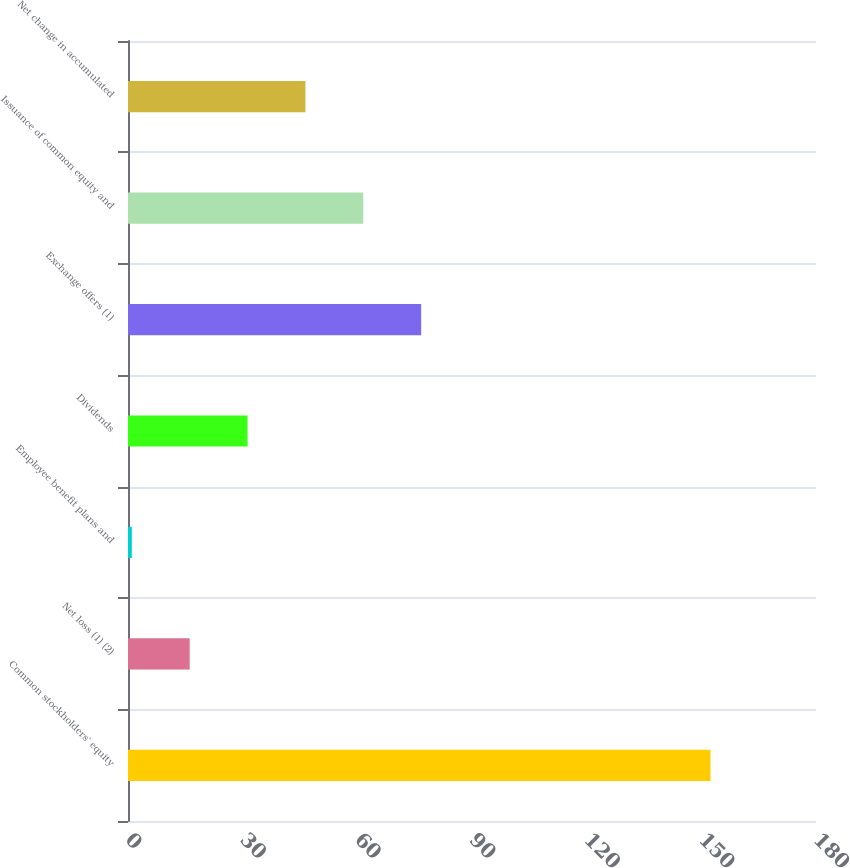<chart> <loc_0><loc_0><loc_500><loc_500><bar_chart><fcel>Common stockholders' equity<fcel>Net loss (1) (2)<fcel>Employee benefit plans and<fcel>Dividends<fcel>Exchange offers (1)<fcel>Issuance of common equity and<fcel>Net change in accumulated<nl><fcel>152.4<fcel>16.14<fcel>1<fcel>31.28<fcel>76.7<fcel>61.56<fcel>46.42<nl></chart> 